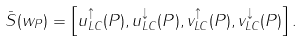Convert formula to latex. <formula><loc_0><loc_0><loc_500><loc_500>\bar { S } ( w _ { P } ) = \left [ u _ { L C } ^ { \uparrow } ( P ) , u _ { L C } ^ { \downarrow } ( P ) , v _ { L C } ^ { \uparrow } ( P ) , v _ { L C } ^ { \downarrow } ( P ) \right ] .</formula> 